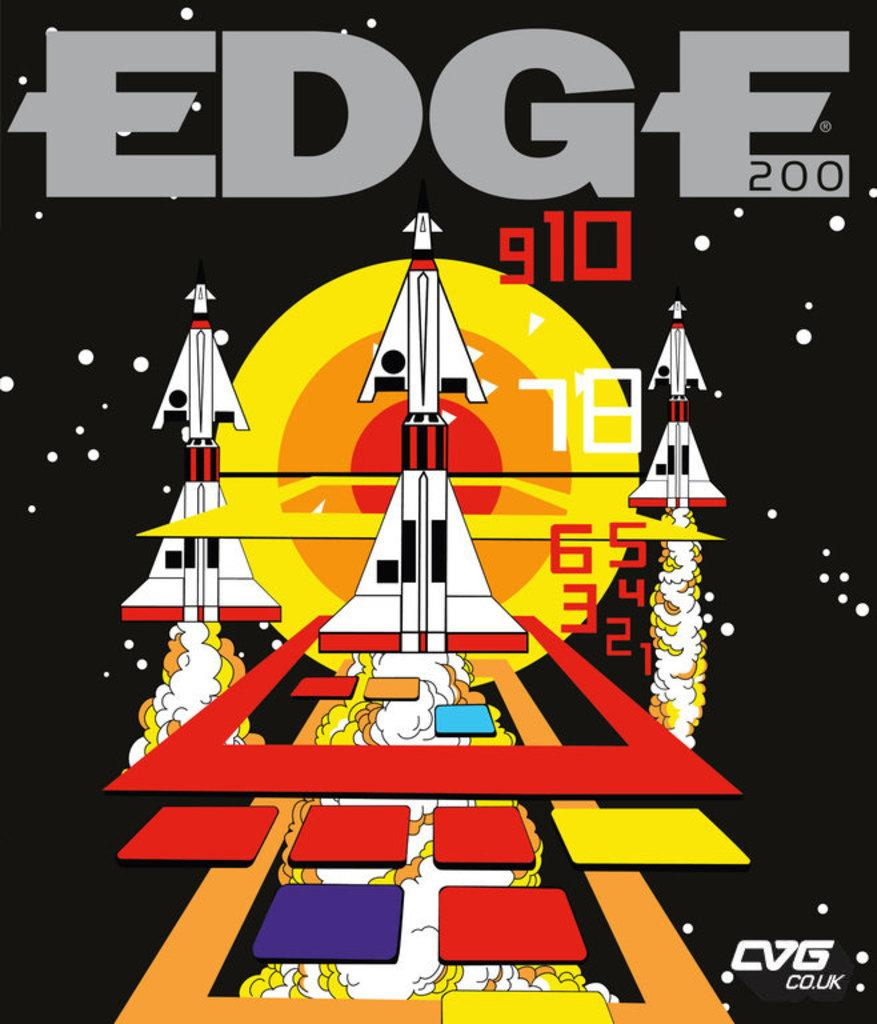What type of items are featured in the image? The image consists of Edge video game magazines. Can you describe the content of the magazines? The content of the magazines is related to video games, as they are Edge video game magazines. How many ants can be seen crawling on the magazines in the image? There are no ants present in the image; it features Edge video game magazines. What is the desire of the person who owns the magazines in the image? The image does not provide any information about the desires of the person who owns the magazines. 